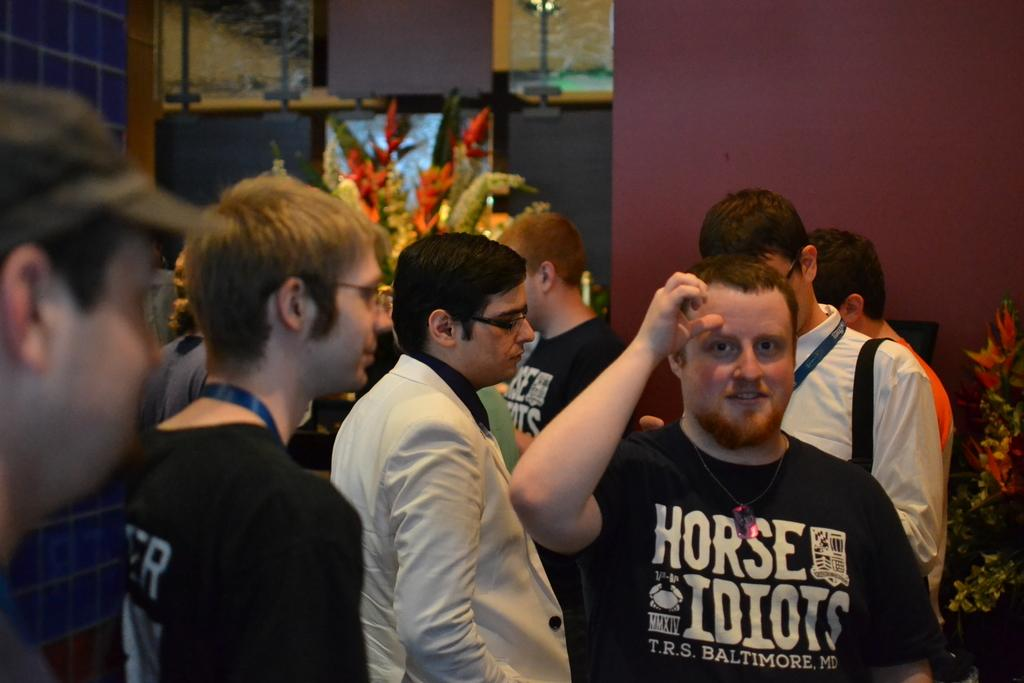How many people are in the image? There are people in the image, but the exact number is not specified. What are the people in the image doing? The people in the image are standing. Are the people in the image looking at something or someone? Yes, the people are looking at someone. What type of paste is being used by the people in the image? There is no mention of paste in the image, so it cannot be determined if any type of paste is being used. 